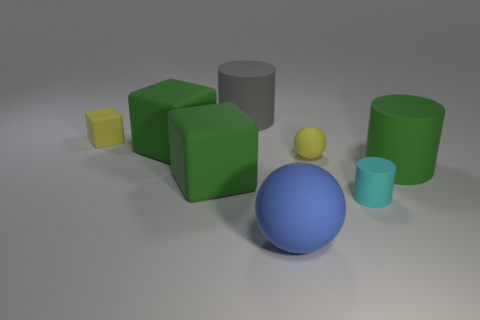Subtract all cyan cylinders. How many cylinders are left? 2 Add 1 blue shiny cylinders. How many objects exist? 9 Subtract all yellow cubes. How many cubes are left? 2 Subtract 1 balls. How many balls are left? 1 Subtract 0 gray balls. How many objects are left? 8 Subtract all cylinders. How many objects are left? 5 Subtract all brown balls. Subtract all brown blocks. How many balls are left? 2 Subtract all yellow blocks. How many yellow spheres are left? 1 Subtract all small purple objects. Subtract all blue things. How many objects are left? 7 Add 4 large gray rubber cylinders. How many large gray rubber cylinders are left? 5 